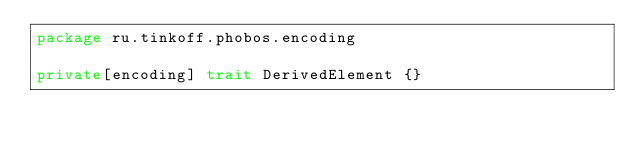<code> <loc_0><loc_0><loc_500><loc_500><_Scala_>package ru.tinkoff.phobos.encoding

private[encoding] trait DerivedElement {}
</code> 